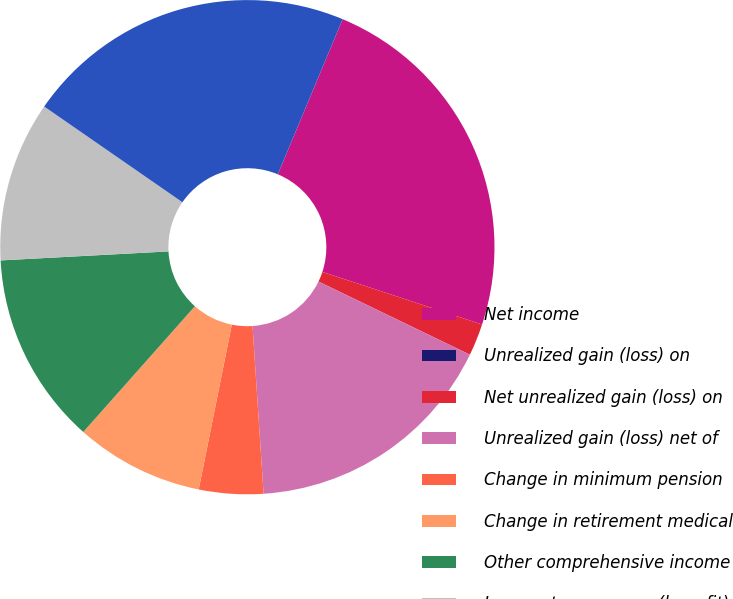<chart> <loc_0><loc_0><loc_500><loc_500><pie_chart><fcel>Net income<fcel>Unrealized gain (loss) on<fcel>Net unrealized gain (loss) on<fcel>Unrealized gain (loss) net of<fcel>Change in minimum pension<fcel>Change in retirement medical<fcel>Other comprehensive income<fcel>Income tax expense (benefit)<fcel>Total comprehensive income<nl><fcel>23.76%<fcel>0.0%<fcel>2.1%<fcel>16.79%<fcel>4.2%<fcel>8.4%<fcel>12.59%<fcel>10.49%<fcel>21.66%<nl></chart> 